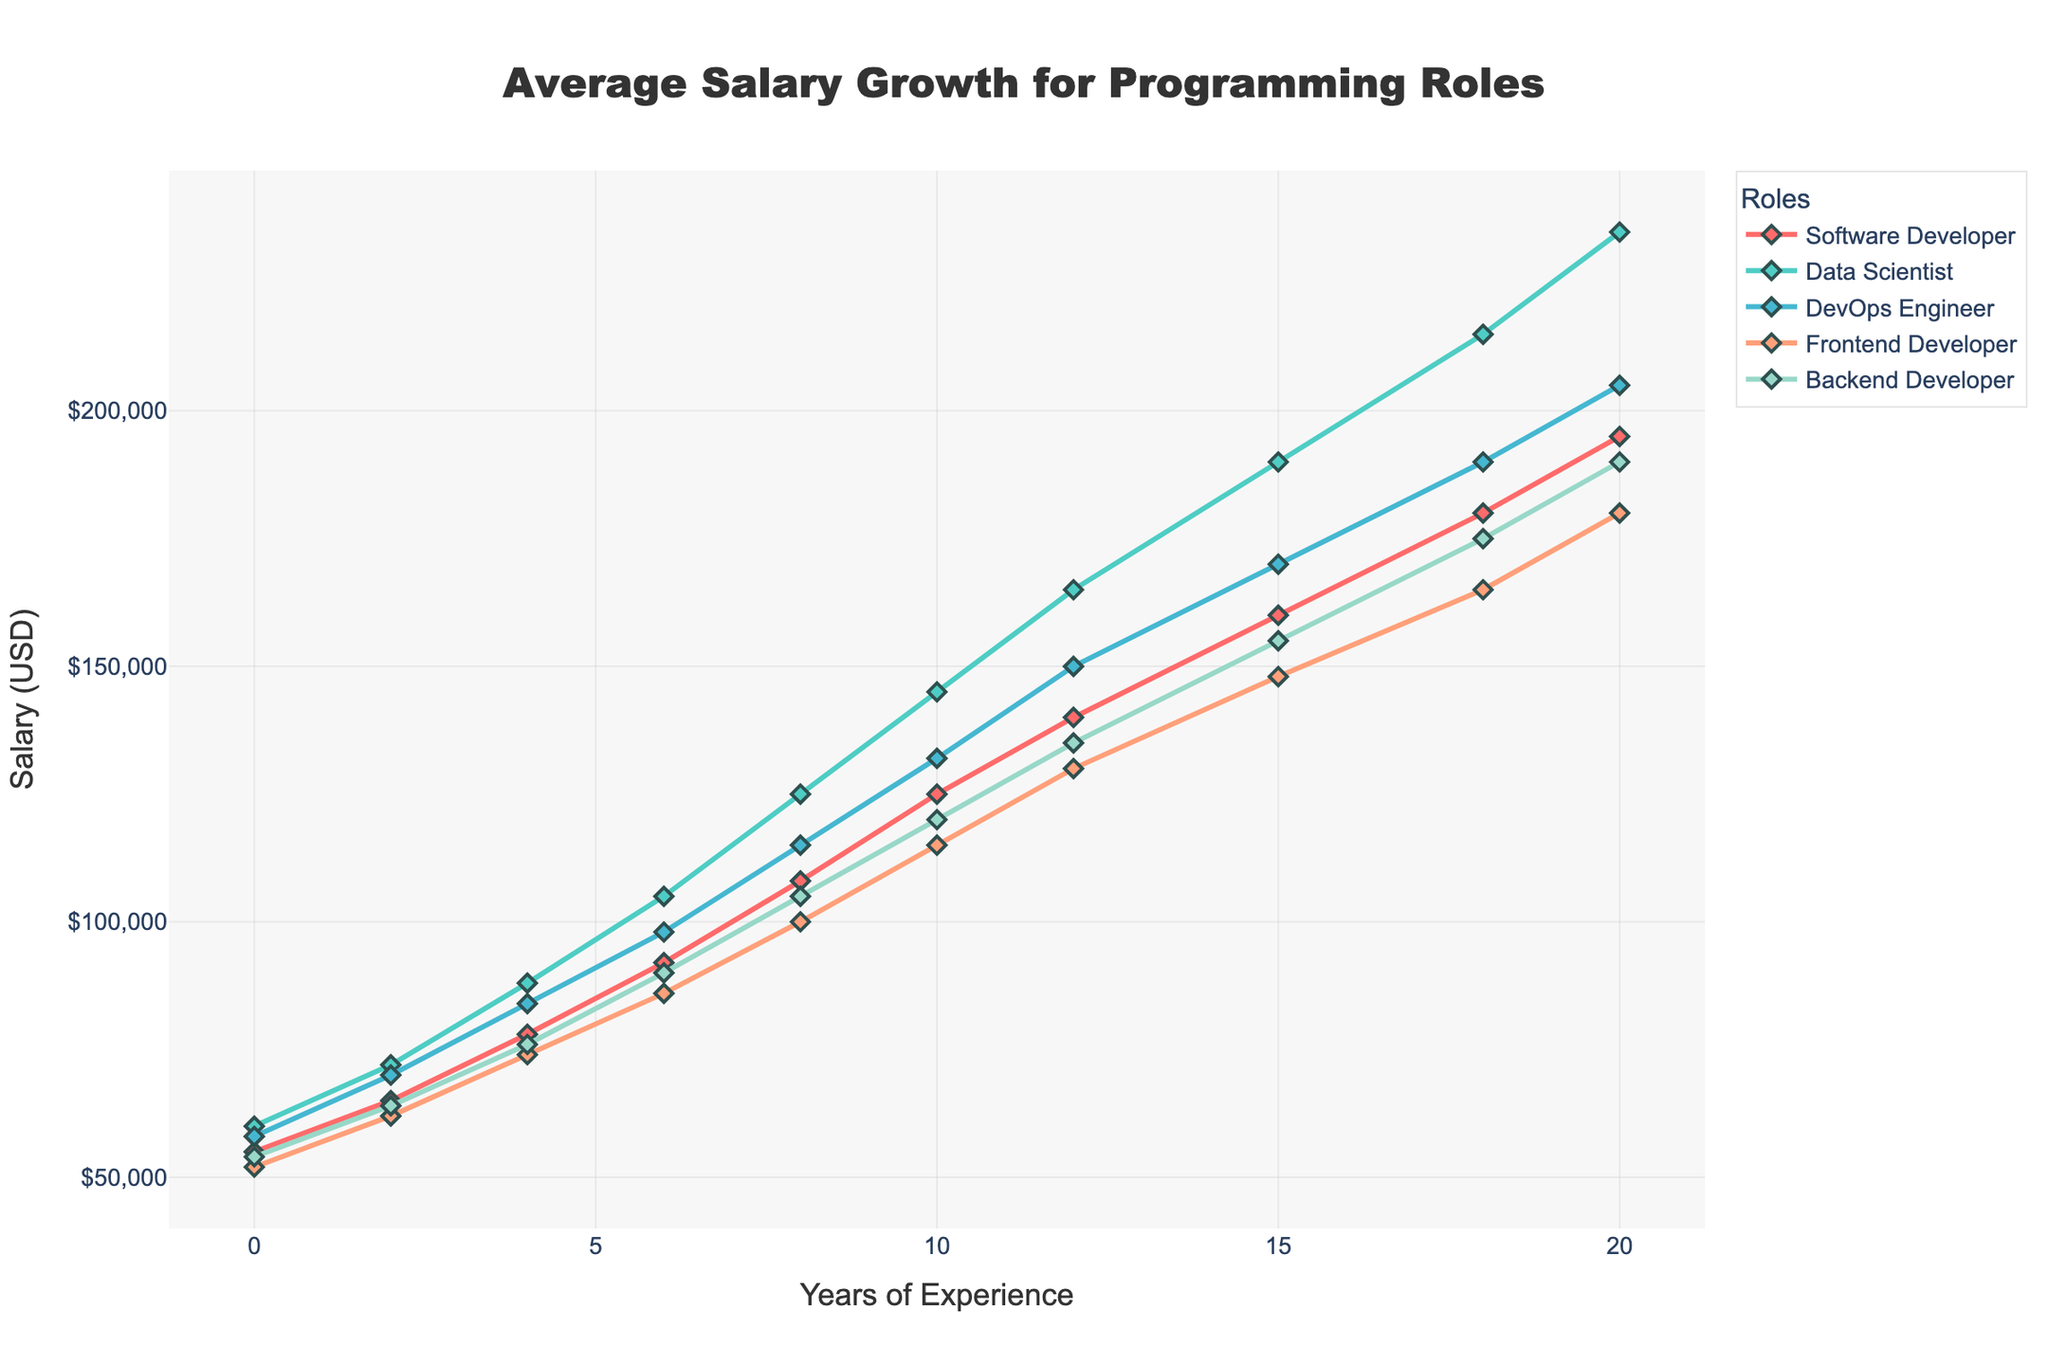What is the average salary of a Data Scientist with 10 years of experience? To find the average salary, refer to the Data Scientist line in the chart at 10 years of experience. The plot value is $145,000.
Answer: $145,000 Which role has the highest starting salary, and what is it? Compare the initial salary values at 0 years of experience for each role: Software Developer, Data Scientist, DevOps Engineer, Frontend Developer, and Backend Developer. The Data Scientist has the highest starting salary of $60,000.
Answer: Data Scientist, $60,000 At 15 years of experience, how much more does a DevOps Engineer make compared to a Frontend Developer? Find the salaries for both roles at 15 years of experience: DevOps Engineer ($170,000) and Frontend Developer ($148,000). Subtract the Frontend Developer's salary from the DevOps Engineer's salary: $170,000 - $148,000 = $22,000.
Answer: $22,000 Which role shows the steepest salary growth between 0 and 8 years of experience? Calculate the difference in salaries between 0 and 8 years of experience for each role and identify the largest increase. Data Scientist: $125,000 - $60,000 = $65,000, shows the steepest growth.
Answer: Data Scientist Between 12 and 20 years of experience, which role has the smallest increase in salary? Calculate the difference in salaries between 12 and 20 years for each role and identify the smallest increase: Software Developer: $195,000 - $140,000 = $55,000; Data Scientist: $235,000 - $165,000 = $70,000; DevOps Engineer: $205,000 - $150,000 = $55,000; Frontend Developer: $180,000 - $130,000 = $50,000; Backend Developer: $190,000 - $135,000 = $55,000. The Frontend Developer has the smallest increase of $50,000.
Answer: Frontend Developer What is the combined salary of a Software Developer and a Backend Developer with 6 years of experience? Find the salaries for both roles at 6 years of experience: Software Developer ($92,000) and Backend Developer ($90,000). Add them together: $92,000 + $90,000 = $182,000.
Answer: $182,000 Between 4 and 10 years of experience, how much more does a Data Scientist's salary increase compared to a Software Developer's? Calculate the difference in salaries for both roles between 4 and 10 years: Data Scientist: $145,000 - $88,000 = $57,000, Software Developer: $125,000 - $78,000 = $47,000. Subtract the increase of the Software Developer from that of the Data Scientist: $57,000 - $47,000 = $10,000.
Answer: $10,000 Which role, if any, has salaries that exceed $200,000, and at what years of experience does this occur? Identify roles with salary values exceeding $200,000 on the chart and the corresponding years of experience: The Data Scientist role exceeds $200,000 starting at 18 years of experience ($215,000) and continues at 20 years of experience ($235,000).
Answer: Data Scientist, 18 and 20 years What is the salary difference between a DevOps Engineer and a Backend Developer at 20 years of experience? Find the salaries for both roles at 20 years of experience: DevOps Engineer ($205,000) and Backend Developer ($190,000). Subtract the Backend Developer's salary from the DevOps Engineer's salary: $205,000 - $190,000 = $15,000.
Answer: $15,000 